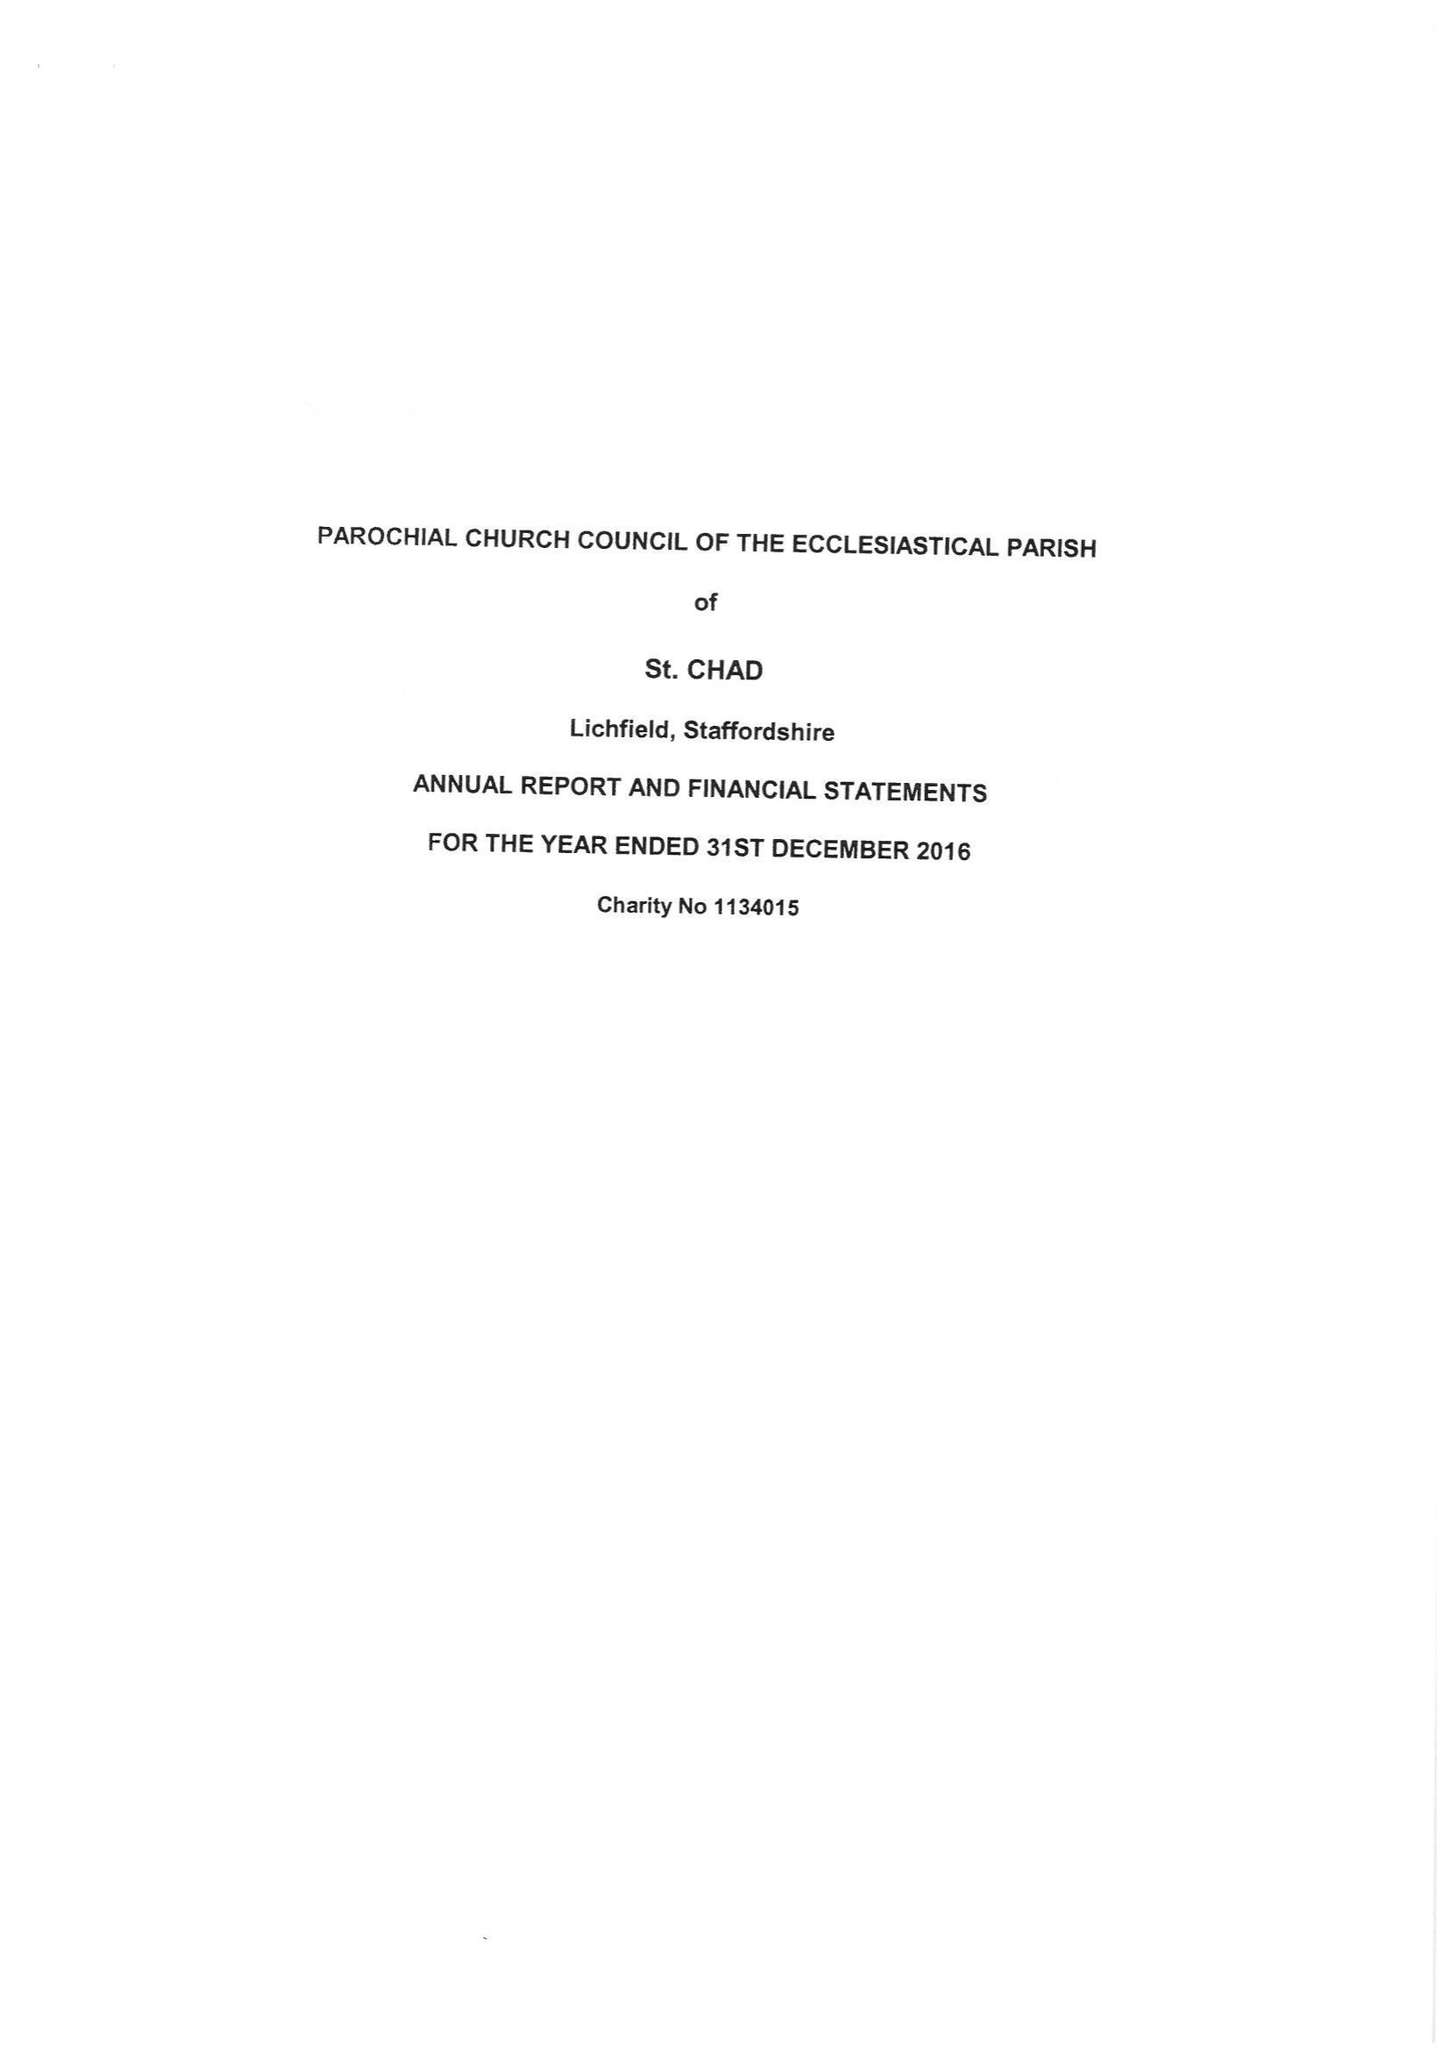What is the value for the charity_number?
Answer the question using a single word or phrase. 1134015 